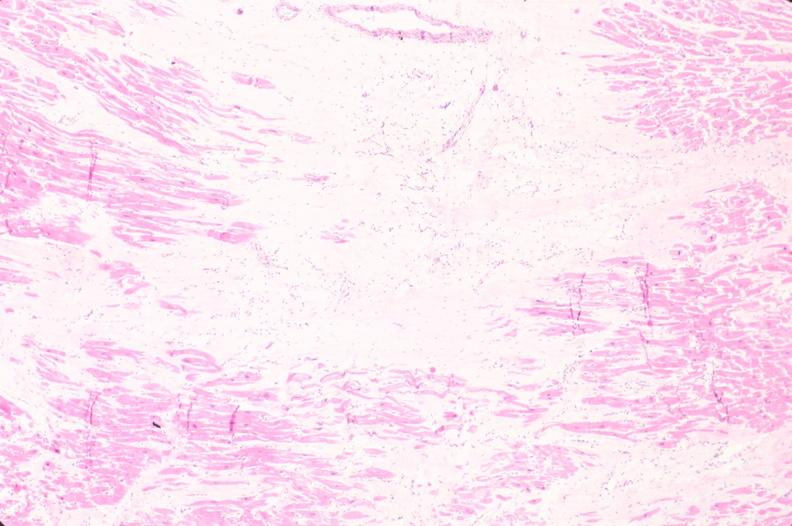what does this image show?
Answer the question using a single word or phrase. Heart 